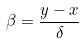<formula> <loc_0><loc_0><loc_500><loc_500>\beta = \frac { y - x } { \delta }</formula> 